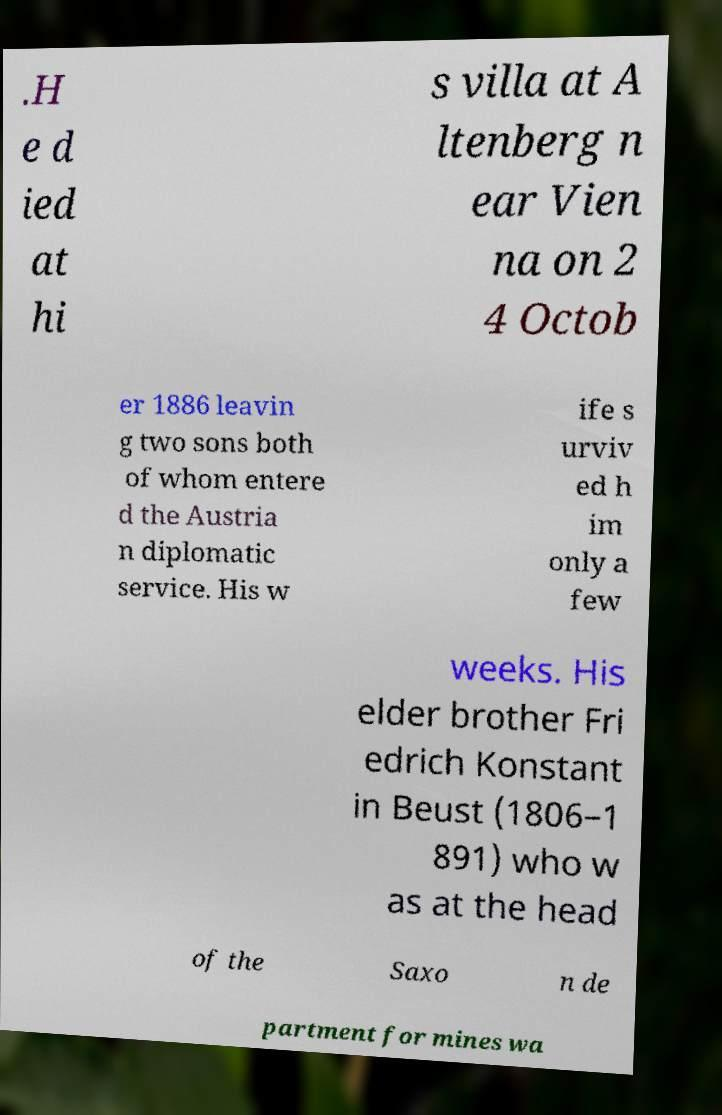There's text embedded in this image that I need extracted. Can you transcribe it verbatim? .H e d ied at hi s villa at A ltenberg n ear Vien na on 2 4 Octob er 1886 leavin g two sons both of whom entere d the Austria n diplomatic service. His w ife s urviv ed h im only a few weeks. His elder brother Fri edrich Konstant in Beust (1806–1 891) who w as at the head of the Saxo n de partment for mines wa 